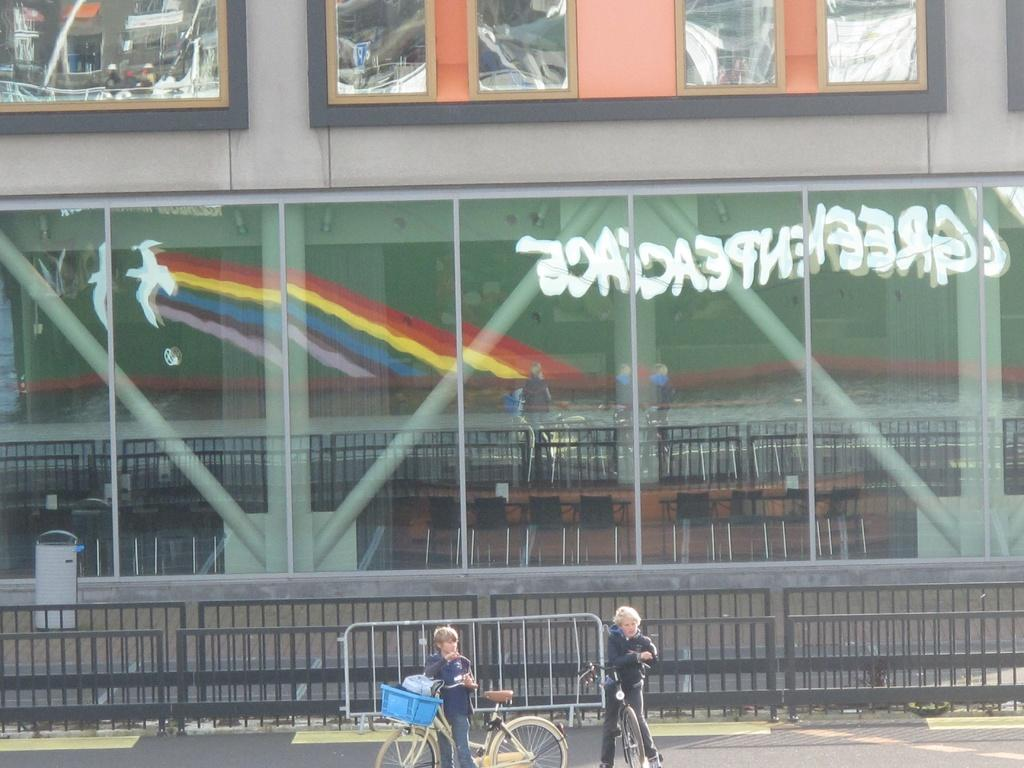Provide a one-sentence caption for the provided image. a store front that has white writing on it and a rainbow. 